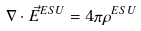Convert formula to latex. <formula><loc_0><loc_0><loc_500><loc_500>\nabla \cdot { \vec { E } } ^ { E S U } = 4 \pi \rho ^ { E S U }</formula> 